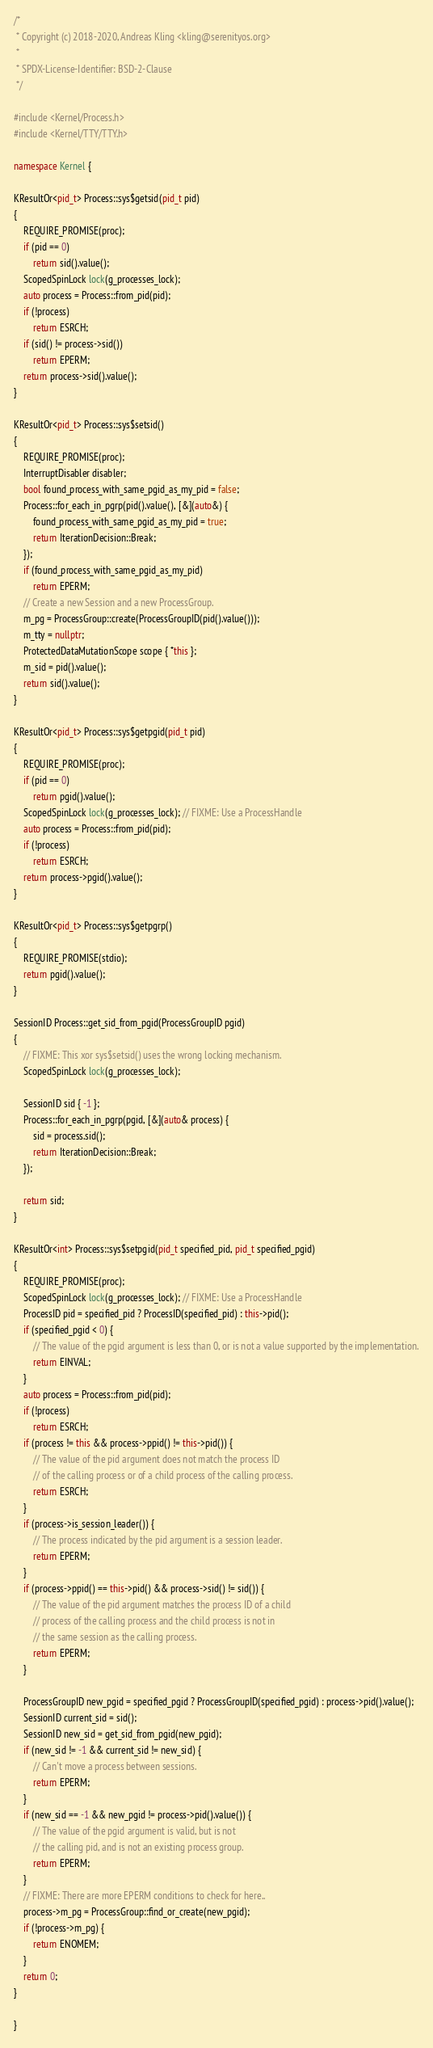Convert code to text. <code><loc_0><loc_0><loc_500><loc_500><_C++_>/*
 * Copyright (c) 2018-2020, Andreas Kling <kling@serenityos.org>
 *
 * SPDX-License-Identifier: BSD-2-Clause
 */

#include <Kernel/Process.h>
#include <Kernel/TTY/TTY.h>

namespace Kernel {

KResultOr<pid_t> Process::sys$getsid(pid_t pid)
{
    REQUIRE_PROMISE(proc);
    if (pid == 0)
        return sid().value();
    ScopedSpinLock lock(g_processes_lock);
    auto process = Process::from_pid(pid);
    if (!process)
        return ESRCH;
    if (sid() != process->sid())
        return EPERM;
    return process->sid().value();
}

KResultOr<pid_t> Process::sys$setsid()
{
    REQUIRE_PROMISE(proc);
    InterruptDisabler disabler;
    bool found_process_with_same_pgid_as_my_pid = false;
    Process::for_each_in_pgrp(pid().value(), [&](auto&) {
        found_process_with_same_pgid_as_my_pid = true;
        return IterationDecision::Break;
    });
    if (found_process_with_same_pgid_as_my_pid)
        return EPERM;
    // Create a new Session and a new ProcessGroup.
    m_pg = ProcessGroup::create(ProcessGroupID(pid().value()));
    m_tty = nullptr;
    ProtectedDataMutationScope scope { *this };
    m_sid = pid().value();
    return sid().value();
}

KResultOr<pid_t> Process::sys$getpgid(pid_t pid)
{
    REQUIRE_PROMISE(proc);
    if (pid == 0)
        return pgid().value();
    ScopedSpinLock lock(g_processes_lock); // FIXME: Use a ProcessHandle
    auto process = Process::from_pid(pid);
    if (!process)
        return ESRCH;
    return process->pgid().value();
}

KResultOr<pid_t> Process::sys$getpgrp()
{
    REQUIRE_PROMISE(stdio);
    return pgid().value();
}

SessionID Process::get_sid_from_pgid(ProcessGroupID pgid)
{
    // FIXME: This xor sys$setsid() uses the wrong locking mechanism.
    ScopedSpinLock lock(g_processes_lock);

    SessionID sid { -1 };
    Process::for_each_in_pgrp(pgid, [&](auto& process) {
        sid = process.sid();
        return IterationDecision::Break;
    });

    return sid;
}

KResultOr<int> Process::sys$setpgid(pid_t specified_pid, pid_t specified_pgid)
{
    REQUIRE_PROMISE(proc);
    ScopedSpinLock lock(g_processes_lock); // FIXME: Use a ProcessHandle
    ProcessID pid = specified_pid ? ProcessID(specified_pid) : this->pid();
    if (specified_pgid < 0) {
        // The value of the pgid argument is less than 0, or is not a value supported by the implementation.
        return EINVAL;
    }
    auto process = Process::from_pid(pid);
    if (!process)
        return ESRCH;
    if (process != this && process->ppid() != this->pid()) {
        // The value of the pid argument does not match the process ID
        // of the calling process or of a child process of the calling process.
        return ESRCH;
    }
    if (process->is_session_leader()) {
        // The process indicated by the pid argument is a session leader.
        return EPERM;
    }
    if (process->ppid() == this->pid() && process->sid() != sid()) {
        // The value of the pid argument matches the process ID of a child
        // process of the calling process and the child process is not in
        // the same session as the calling process.
        return EPERM;
    }

    ProcessGroupID new_pgid = specified_pgid ? ProcessGroupID(specified_pgid) : process->pid().value();
    SessionID current_sid = sid();
    SessionID new_sid = get_sid_from_pgid(new_pgid);
    if (new_sid != -1 && current_sid != new_sid) {
        // Can't move a process between sessions.
        return EPERM;
    }
    if (new_sid == -1 && new_pgid != process->pid().value()) {
        // The value of the pgid argument is valid, but is not
        // the calling pid, and is not an existing process group.
        return EPERM;
    }
    // FIXME: There are more EPERM conditions to check for here..
    process->m_pg = ProcessGroup::find_or_create(new_pgid);
    if (!process->m_pg) {
        return ENOMEM;
    }
    return 0;
}

}
</code> 